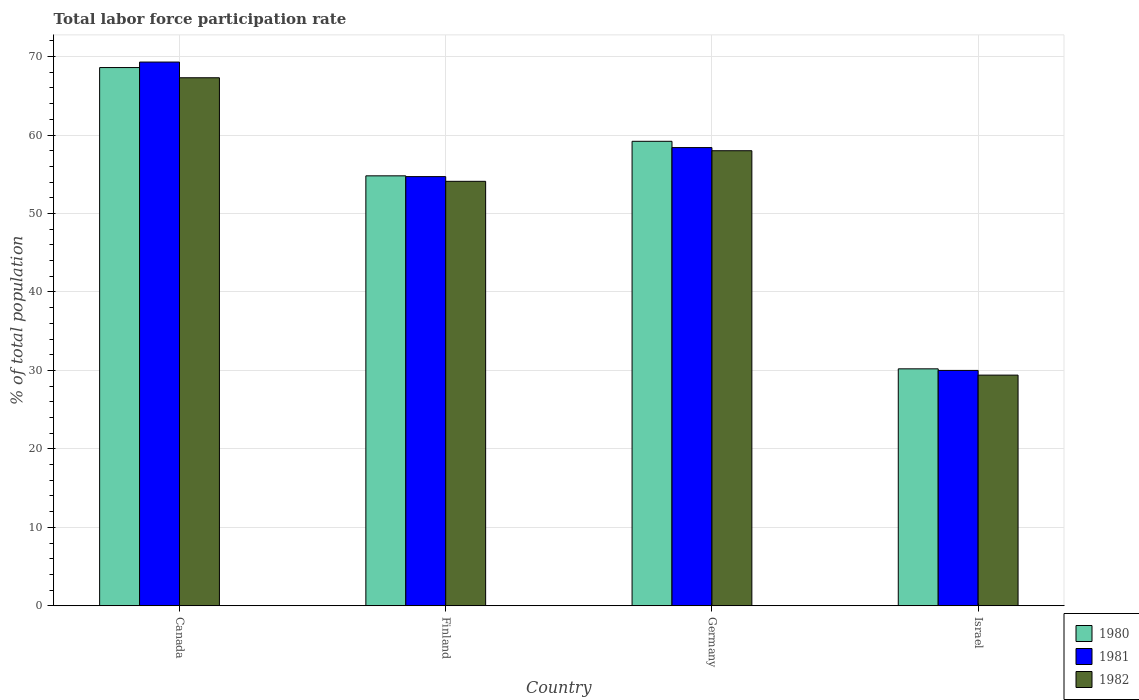How many groups of bars are there?
Provide a succinct answer. 4. Are the number of bars per tick equal to the number of legend labels?
Provide a succinct answer. Yes. How many bars are there on the 2nd tick from the left?
Keep it short and to the point. 3. What is the label of the 4th group of bars from the left?
Provide a succinct answer. Israel. What is the total labor force participation rate in 1980 in Finland?
Make the answer very short. 54.8. Across all countries, what is the maximum total labor force participation rate in 1981?
Provide a succinct answer. 69.3. Across all countries, what is the minimum total labor force participation rate in 1980?
Provide a short and direct response. 30.2. In which country was the total labor force participation rate in 1980 minimum?
Keep it short and to the point. Israel. What is the total total labor force participation rate in 1982 in the graph?
Ensure brevity in your answer.  208.8. What is the difference between the total labor force participation rate in 1981 in Canada and that in Finland?
Provide a short and direct response. 14.6. What is the difference between the total labor force participation rate in 1980 in Canada and the total labor force participation rate in 1981 in Finland?
Offer a terse response. 13.9. What is the average total labor force participation rate in 1982 per country?
Your answer should be very brief. 52.2. What is the difference between the total labor force participation rate of/in 1980 and total labor force participation rate of/in 1982 in Israel?
Give a very brief answer. 0.8. In how many countries, is the total labor force participation rate in 1980 greater than 68 %?
Ensure brevity in your answer.  1. What is the ratio of the total labor force participation rate in 1981 in Canada to that in Finland?
Offer a very short reply. 1.27. What is the difference between the highest and the second highest total labor force participation rate in 1981?
Offer a terse response. -10.9. What is the difference between the highest and the lowest total labor force participation rate in 1982?
Offer a terse response. 37.9. What does the 3rd bar from the right in Finland represents?
Make the answer very short. 1980. Is it the case that in every country, the sum of the total labor force participation rate in 1981 and total labor force participation rate in 1980 is greater than the total labor force participation rate in 1982?
Offer a very short reply. Yes. How many countries are there in the graph?
Keep it short and to the point. 4. What is the difference between two consecutive major ticks on the Y-axis?
Ensure brevity in your answer.  10. Does the graph contain any zero values?
Ensure brevity in your answer.  No. Does the graph contain grids?
Keep it short and to the point. Yes. Where does the legend appear in the graph?
Offer a terse response. Bottom right. How many legend labels are there?
Keep it short and to the point. 3. How are the legend labels stacked?
Ensure brevity in your answer.  Vertical. What is the title of the graph?
Your answer should be very brief. Total labor force participation rate. What is the label or title of the X-axis?
Your answer should be very brief. Country. What is the label or title of the Y-axis?
Your response must be concise. % of total population. What is the % of total population of 1980 in Canada?
Offer a very short reply. 68.6. What is the % of total population in 1981 in Canada?
Provide a short and direct response. 69.3. What is the % of total population in 1982 in Canada?
Make the answer very short. 67.3. What is the % of total population of 1980 in Finland?
Keep it short and to the point. 54.8. What is the % of total population in 1981 in Finland?
Offer a very short reply. 54.7. What is the % of total population of 1982 in Finland?
Your answer should be very brief. 54.1. What is the % of total population of 1980 in Germany?
Your response must be concise. 59.2. What is the % of total population in 1981 in Germany?
Ensure brevity in your answer.  58.4. What is the % of total population of 1982 in Germany?
Your answer should be compact. 58. What is the % of total population of 1980 in Israel?
Keep it short and to the point. 30.2. What is the % of total population of 1981 in Israel?
Provide a succinct answer. 30. What is the % of total population of 1982 in Israel?
Offer a very short reply. 29.4. Across all countries, what is the maximum % of total population in 1980?
Offer a terse response. 68.6. Across all countries, what is the maximum % of total population in 1981?
Keep it short and to the point. 69.3. Across all countries, what is the maximum % of total population of 1982?
Offer a terse response. 67.3. Across all countries, what is the minimum % of total population in 1980?
Your answer should be compact. 30.2. Across all countries, what is the minimum % of total population of 1982?
Give a very brief answer. 29.4. What is the total % of total population in 1980 in the graph?
Give a very brief answer. 212.8. What is the total % of total population of 1981 in the graph?
Offer a terse response. 212.4. What is the total % of total population in 1982 in the graph?
Offer a very short reply. 208.8. What is the difference between the % of total population of 1980 in Canada and that in Finland?
Give a very brief answer. 13.8. What is the difference between the % of total population of 1981 in Canada and that in Finland?
Keep it short and to the point. 14.6. What is the difference between the % of total population of 1982 in Canada and that in Finland?
Your answer should be very brief. 13.2. What is the difference between the % of total population of 1980 in Canada and that in Germany?
Provide a succinct answer. 9.4. What is the difference between the % of total population of 1982 in Canada and that in Germany?
Make the answer very short. 9.3. What is the difference between the % of total population of 1980 in Canada and that in Israel?
Provide a succinct answer. 38.4. What is the difference between the % of total population of 1981 in Canada and that in Israel?
Provide a succinct answer. 39.3. What is the difference between the % of total population in 1982 in Canada and that in Israel?
Offer a terse response. 37.9. What is the difference between the % of total population of 1982 in Finland and that in Germany?
Provide a short and direct response. -3.9. What is the difference between the % of total population in 1980 in Finland and that in Israel?
Offer a terse response. 24.6. What is the difference between the % of total population of 1981 in Finland and that in Israel?
Give a very brief answer. 24.7. What is the difference between the % of total population of 1982 in Finland and that in Israel?
Your response must be concise. 24.7. What is the difference between the % of total population of 1981 in Germany and that in Israel?
Provide a succinct answer. 28.4. What is the difference between the % of total population in 1982 in Germany and that in Israel?
Offer a terse response. 28.6. What is the difference between the % of total population of 1980 in Canada and the % of total population of 1981 in Finland?
Offer a very short reply. 13.9. What is the difference between the % of total population of 1981 in Canada and the % of total population of 1982 in Finland?
Provide a succinct answer. 15.2. What is the difference between the % of total population of 1980 in Canada and the % of total population of 1982 in Germany?
Offer a terse response. 10.6. What is the difference between the % of total population of 1981 in Canada and the % of total population of 1982 in Germany?
Provide a short and direct response. 11.3. What is the difference between the % of total population in 1980 in Canada and the % of total population in 1981 in Israel?
Your answer should be compact. 38.6. What is the difference between the % of total population in 1980 in Canada and the % of total population in 1982 in Israel?
Keep it short and to the point. 39.2. What is the difference between the % of total population of 1981 in Canada and the % of total population of 1982 in Israel?
Your response must be concise. 39.9. What is the difference between the % of total population of 1980 in Finland and the % of total population of 1981 in Israel?
Ensure brevity in your answer.  24.8. What is the difference between the % of total population in 1980 in Finland and the % of total population in 1982 in Israel?
Ensure brevity in your answer.  25.4. What is the difference between the % of total population in 1981 in Finland and the % of total population in 1982 in Israel?
Provide a short and direct response. 25.3. What is the difference between the % of total population of 1980 in Germany and the % of total population of 1981 in Israel?
Keep it short and to the point. 29.2. What is the difference between the % of total population in 1980 in Germany and the % of total population in 1982 in Israel?
Offer a very short reply. 29.8. What is the average % of total population of 1980 per country?
Your answer should be very brief. 53.2. What is the average % of total population of 1981 per country?
Offer a terse response. 53.1. What is the average % of total population in 1982 per country?
Provide a short and direct response. 52.2. What is the difference between the % of total population of 1981 and % of total population of 1982 in Canada?
Offer a very short reply. 2. What is the difference between the % of total population of 1980 and % of total population of 1982 in Finland?
Your response must be concise. 0.7. What is the difference between the % of total population of 1980 and % of total population of 1982 in Israel?
Provide a short and direct response. 0.8. What is the ratio of the % of total population of 1980 in Canada to that in Finland?
Give a very brief answer. 1.25. What is the ratio of the % of total population in 1981 in Canada to that in Finland?
Offer a terse response. 1.27. What is the ratio of the % of total population of 1982 in Canada to that in Finland?
Provide a short and direct response. 1.24. What is the ratio of the % of total population of 1980 in Canada to that in Germany?
Keep it short and to the point. 1.16. What is the ratio of the % of total population of 1981 in Canada to that in Germany?
Your answer should be compact. 1.19. What is the ratio of the % of total population of 1982 in Canada to that in Germany?
Ensure brevity in your answer.  1.16. What is the ratio of the % of total population in 1980 in Canada to that in Israel?
Offer a terse response. 2.27. What is the ratio of the % of total population in 1981 in Canada to that in Israel?
Provide a short and direct response. 2.31. What is the ratio of the % of total population in 1982 in Canada to that in Israel?
Make the answer very short. 2.29. What is the ratio of the % of total population in 1980 in Finland to that in Germany?
Your answer should be very brief. 0.93. What is the ratio of the % of total population in 1981 in Finland to that in Germany?
Ensure brevity in your answer.  0.94. What is the ratio of the % of total population of 1982 in Finland to that in Germany?
Give a very brief answer. 0.93. What is the ratio of the % of total population of 1980 in Finland to that in Israel?
Offer a terse response. 1.81. What is the ratio of the % of total population of 1981 in Finland to that in Israel?
Offer a terse response. 1.82. What is the ratio of the % of total population of 1982 in Finland to that in Israel?
Your response must be concise. 1.84. What is the ratio of the % of total population of 1980 in Germany to that in Israel?
Make the answer very short. 1.96. What is the ratio of the % of total population of 1981 in Germany to that in Israel?
Offer a terse response. 1.95. What is the ratio of the % of total population in 1982 in Germany to that in Israel?
Offer a very short reply. 1.97. What is the difference between the highest and the second highest % of total population of 1980?
Keep it short and to the point. 9.4. What is the difference between the highest and the second highest % of total population in 1981?
Offer a very short reply. 10.9. What is the difference between the highest and the second highest % of total population in 1982?
Your answer should be compact. 9.3. What is the difference between the highest and the lowest % of total population of 1980?
Offer a very short reply. 38.4. What is the difference between the highest and the lowest % of total population of 1981?
Provide a short and direct response. 39.3. What is the difference between the highest and the lowest % of total population in 1982?
Your answer should be very brief. 37.9. 